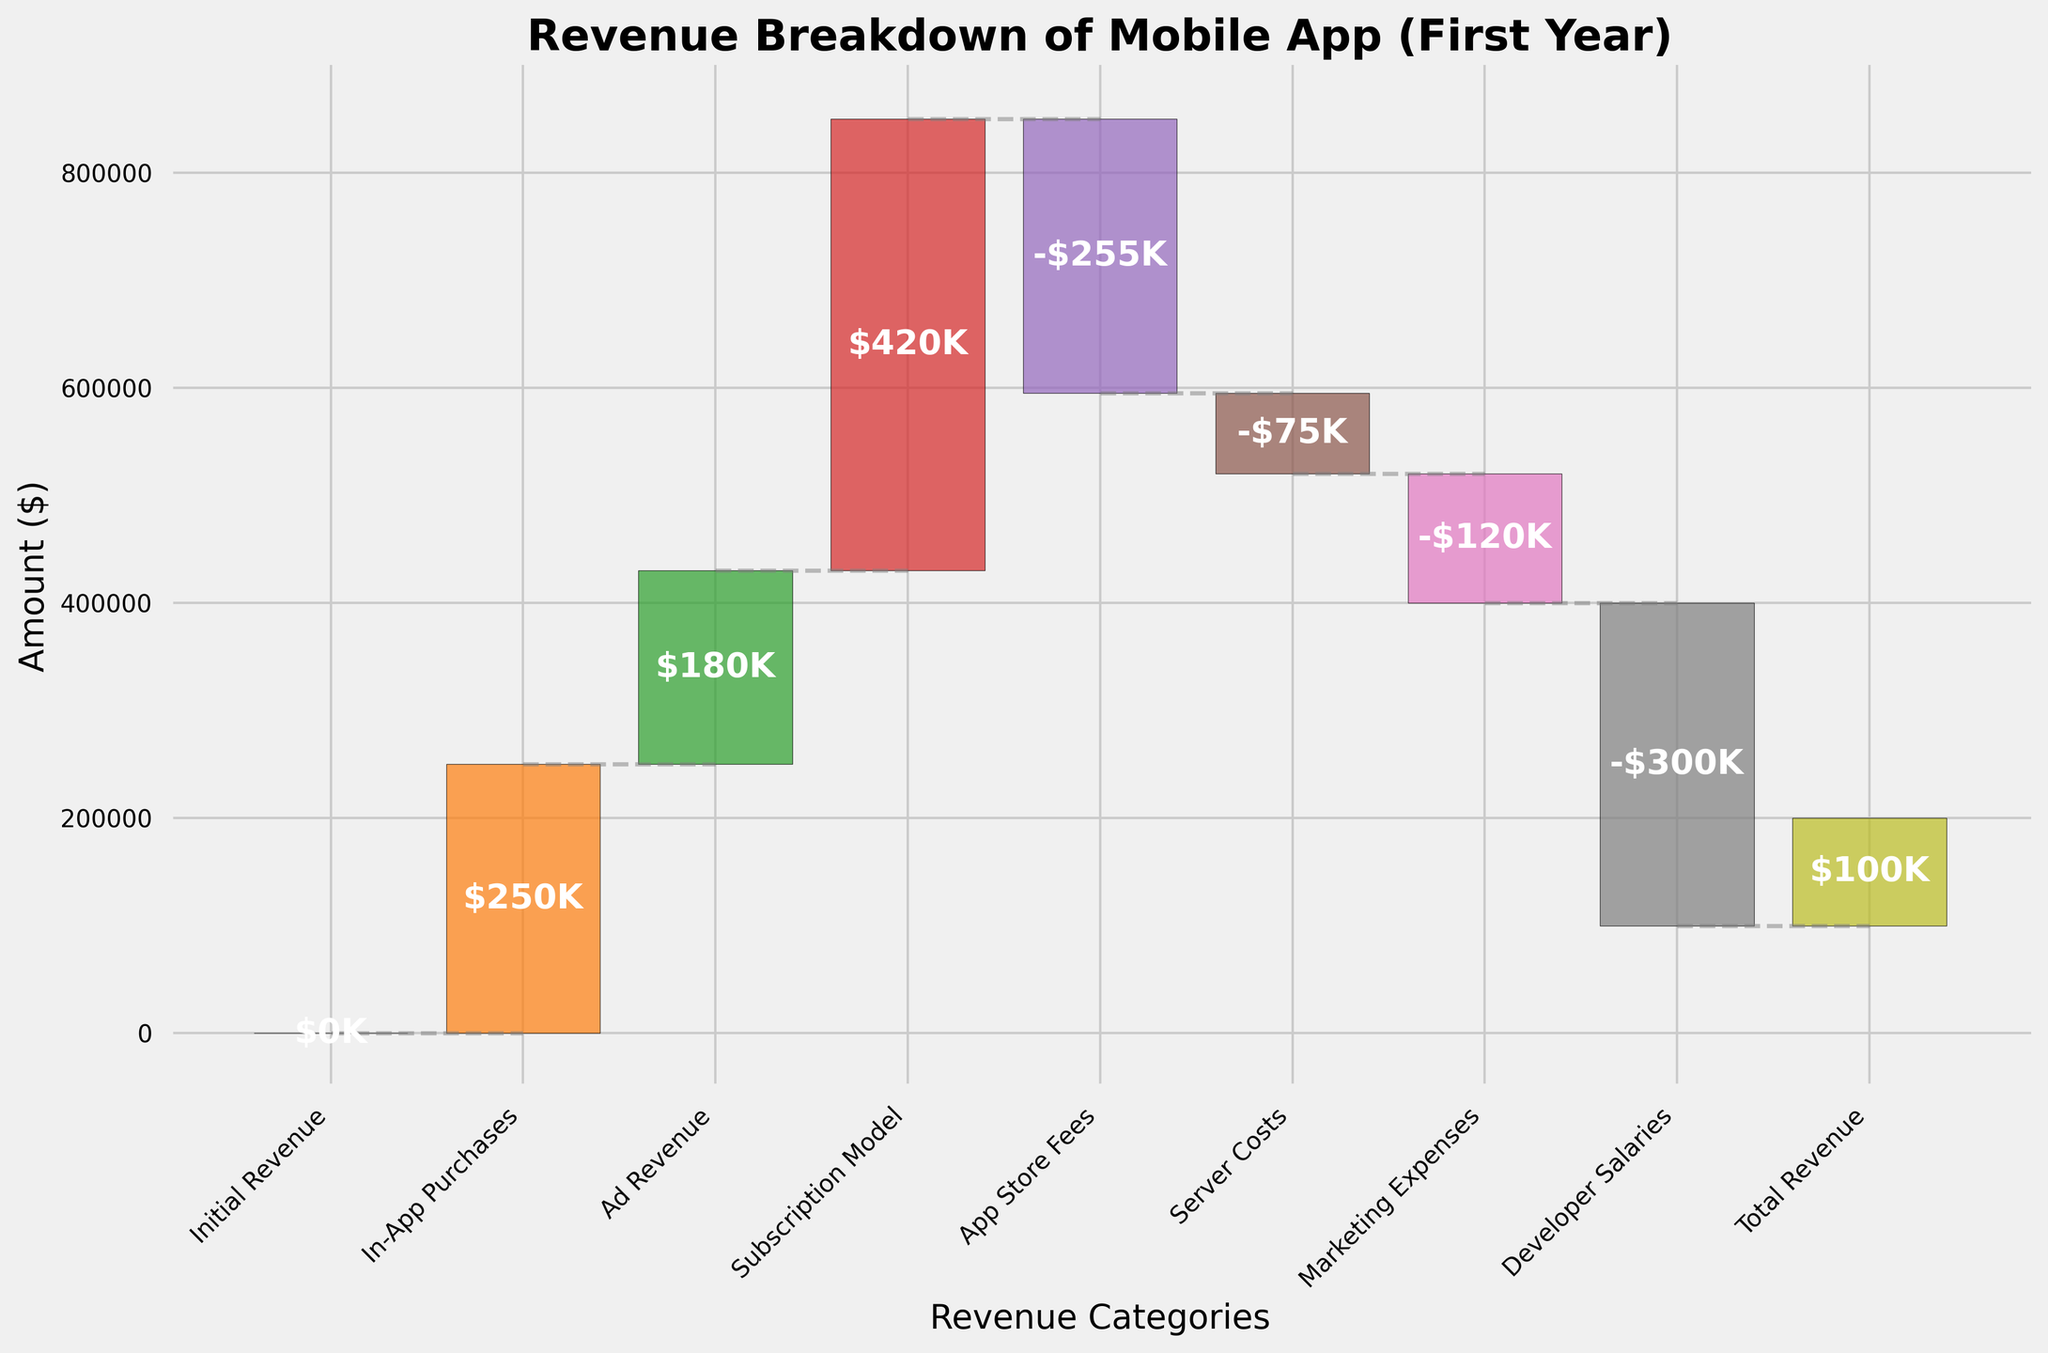What is the title of the figure? The title is the text at the top of the chart, large, and bold, summarizing the content of the figure. Look at the top of the chart for the title.
Answer: Revenue Breakdown of Mobile App (First Year) What are the categories listed on the x-axis? The x-axis labels describe different segments contributing to the revenue breakdown. Reading from left to right, list each category.
Answer: Initial Revenue, In-App Purchases, Ad Revenue, Subscription Model, App Store Fees, Server Costs, Marketing Expenses, Developer Salaries, Total Revenue How much revenue did Ad Revenue contribute? Locate the Ad Revenue bar in the chart and read the number displayed at the center of the bar. This bar represents the revenue generated from ads.
Answer: $180K What is the total revenue at the end of the year? The final bar labeled "Total Revenue" shows the overall revenue the app has accumulated. Look at the top of this final bar to find the value.
Answer: $100K Which category incurred the highest cost, and how much was it? Identify the bars with negative values representing costs. The one with the highest negative value is the highest cost. Check the value at the center of this bar.
Answer: Developer Salaries, -$300K Comparing In-App Purchases and Subscription Model, which generated more revenue? Compare the height and value shown on the bars for both categories. The taller bar with a higher number represents more revenue.
Answer: Subscription Model Calculate the combined revenue from In-App Purchases and Ad Revenue. Locate the bars for In-App Purchases and Ad Revenue. Add their values together: $250K + $180K
Answer: $430K What is the difference between App Store Fees and Server Costs? Identify the values for App Store Fees and Server Costs and subtract the smaller from the larger value to find the difference: $255K - $75K
Answer: $180K How much did Marketing Expenses and Developer Salaries cost in total? Locate the bars for Marketing Expenses and Developer Salaries. Add their negative values together: -$120K + (-$300K)
Answer: -$420K Is the revenue from Subscription Model greater than the sum of Server Costs and Marketing Expenses? Compare the revenue from Subscription Model to the sum of Server Costs and Marketing Expenses. Calculate if $420K > $(-75K + -120K)
Answer: Yes 